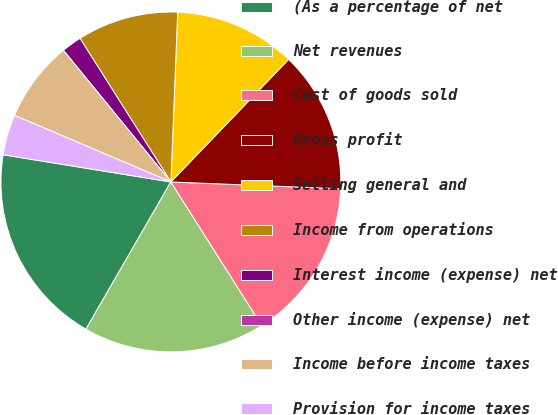Convert chart to OTSL. <chart><loc_0><loc_0><loc_500><loc_500><pie_chart><fcel>(As a percentage of net<fcel>Net revenues<fcel>Cost of goods sold<fcel>Gross profit<fcel>Selling general and<fcel>Income from operations<fcel>Interest income (expense) net<fcel>Other income (expense) net<fcel>Income before income taxes<fcel>Provision for income taxes<nl><fcel>19.23%<fcel>17.31%<fcel>15.38%<fcel>13.46%<fcel>11.54%<fcel>9.62%<fcel>1.92%<fcel>0.0%<fcel>7.69%<fcel>3.85%<nl></chart> 